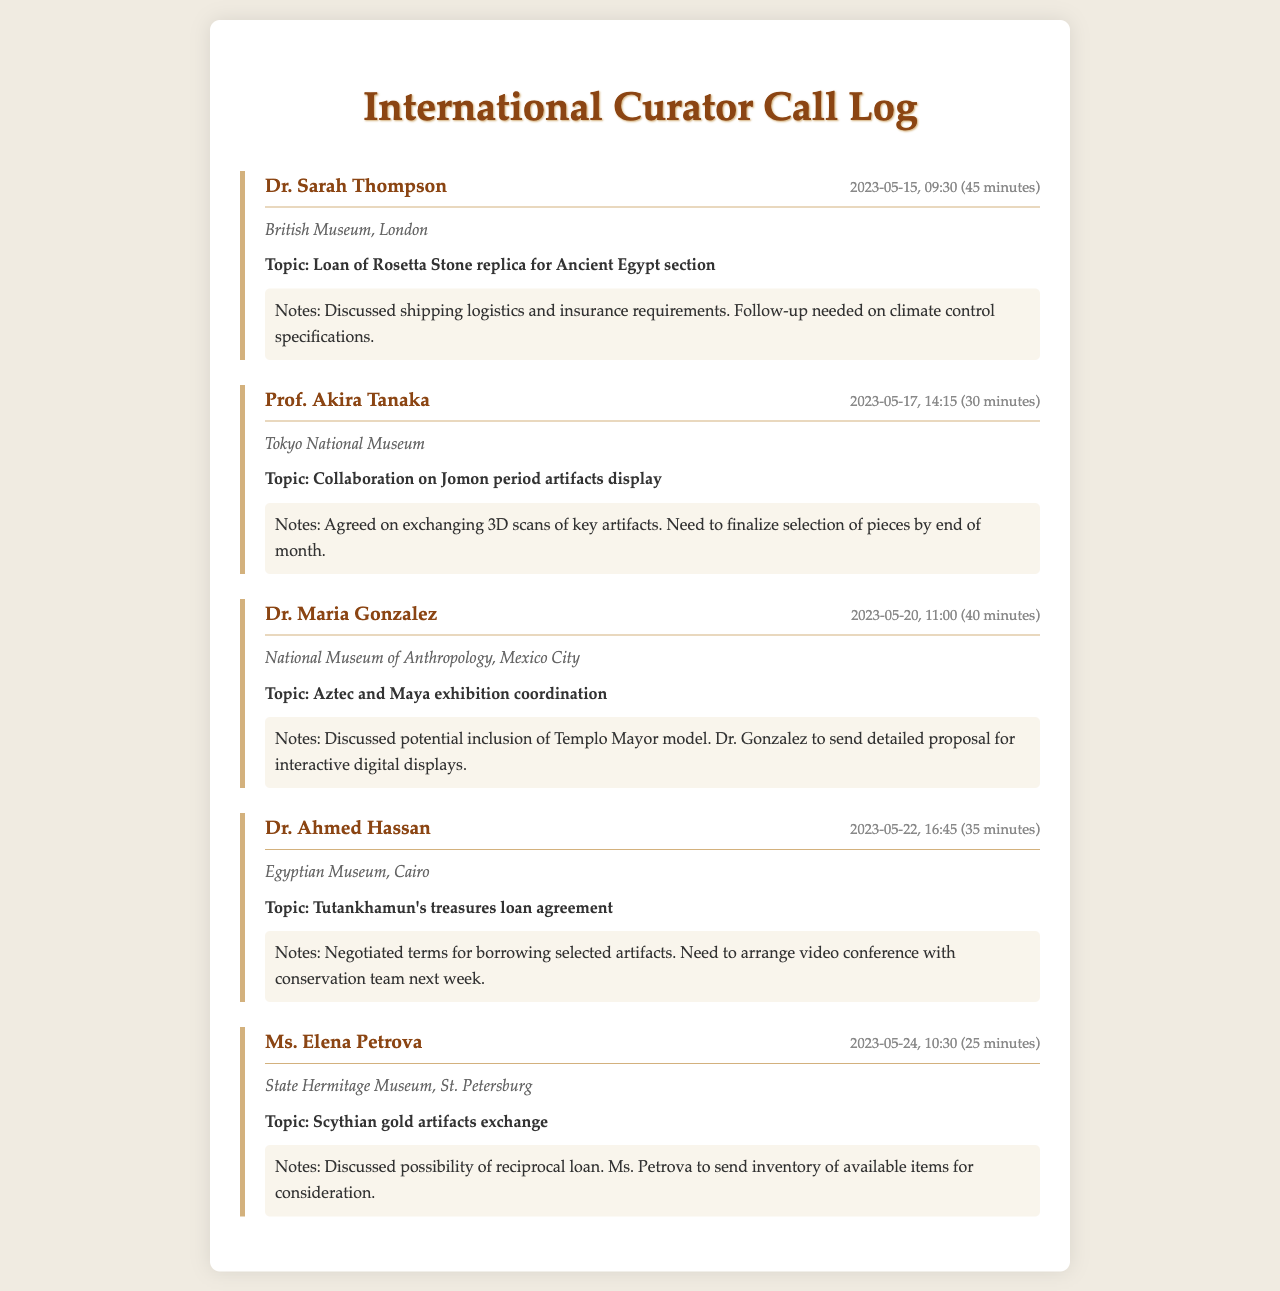What is the date of the call with Dr. Sarah Thompson? The call took place on May 15, 2023, according to the log.
Answer: May 15, 2023 How long was the call with Prof. Akira Tanaka? The call lasted for 30 minutes, as indicated in the document.
Answer: 30 minutes What institution is Dr. Maria Gonzalez affiliated with? The document states that Dr. Gonzalez is with the National Museum of Anthropology, Mexico City.
Answer: National Museum of Anthropology, Mexico City What topic was discussed during the call with Ms. Elena Petrova? The call focused on the exchange of Scythian gold artifacts.
Answer: Scythian gold artifacts exchange How many minutes did the call with Dr. Ahmed Hassan last? The duration of the call is mentioned as 35 minutes.
Answer: 35 minutes What was agreed upon in the call with Prof. Akira Tanaka? They agreed on exchanging 3D scans of key artifacts, as per the notes.
Answer: Exchanging 3D scans What call topic requires a follow-up on logistics? The topic involving shipping logistics and insurance requirements for the Rosetta Stone replica requires a follow-up.
Answer: Loan of Rosetta Stone replica Who is responsible for sending a detailed proposal for exhibition displays? Dr. Gonzalez is to send the detailed proposal for interactive digital displays.
Answer: Dr. Maria Gonzalez Which curator mentioned arranging a video conference? Dr. Ahmed Hassan mentioned the need to arrange a video conference.
Answer: Dr. Ahmed Hassan 